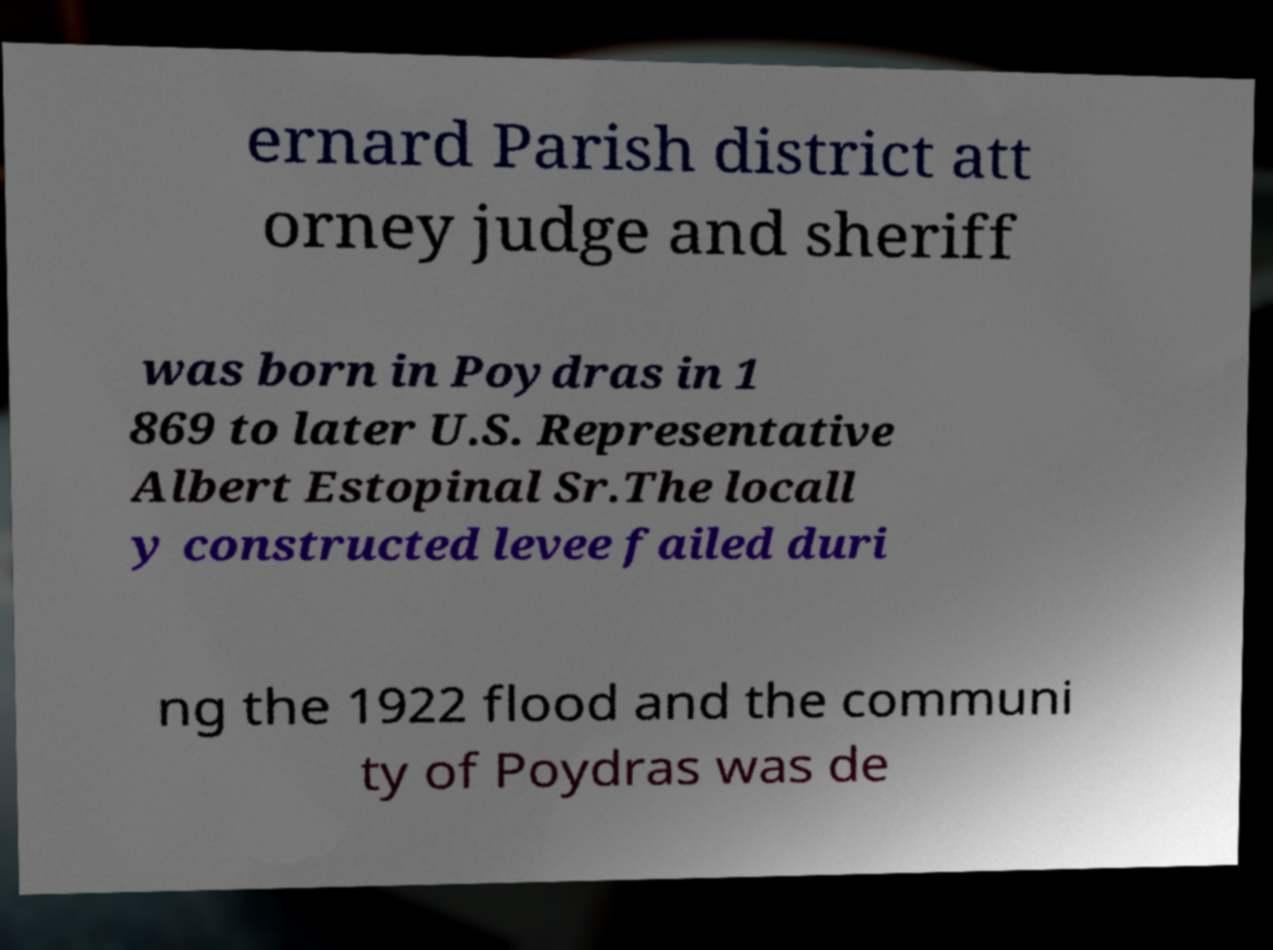I need the written content from this picture converted into text. Can you do that? ernard Parish district att orney judge and sheriff was born in Poydras in 1 869 to later U.S. Representative Albert Estopinal Sr.The locall y constructed levee failed duri ng the 1922 flood and the communi ty of Poydras was de 